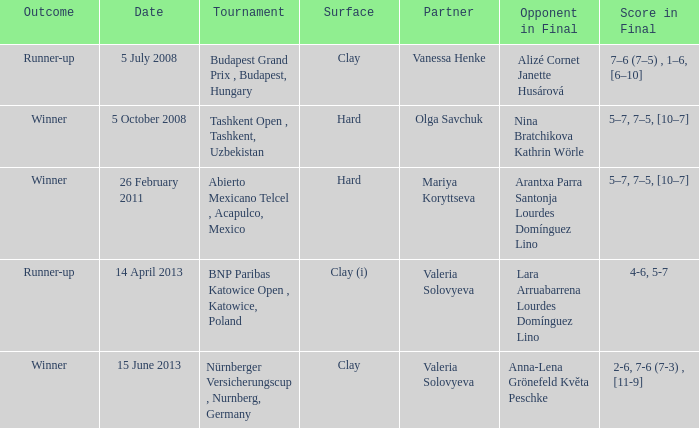Specify the consequence that featured an adversary in the ultimate showdown of nina bratchikova and kathrin wörle. Winner. 